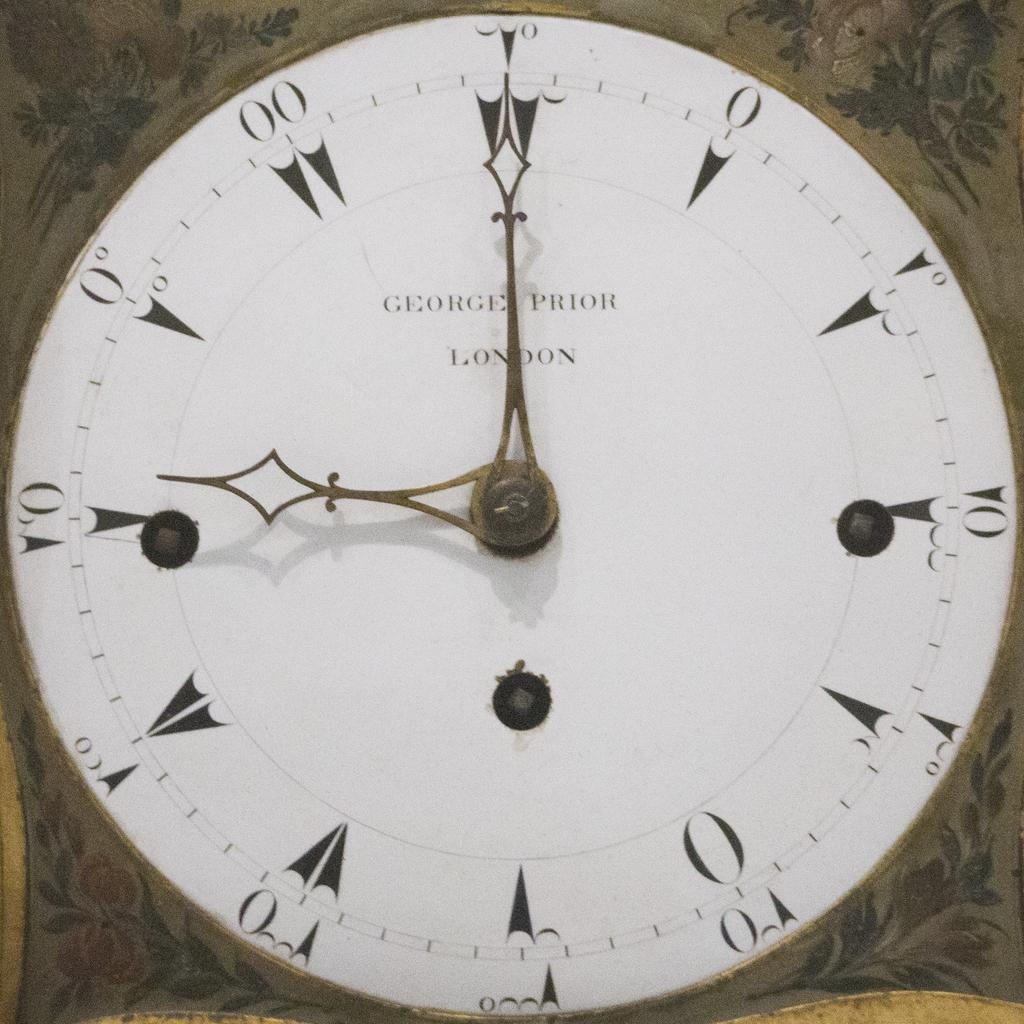<image>
Present a compact description of the photo's key features. A white clock says George Prior London on the face. 